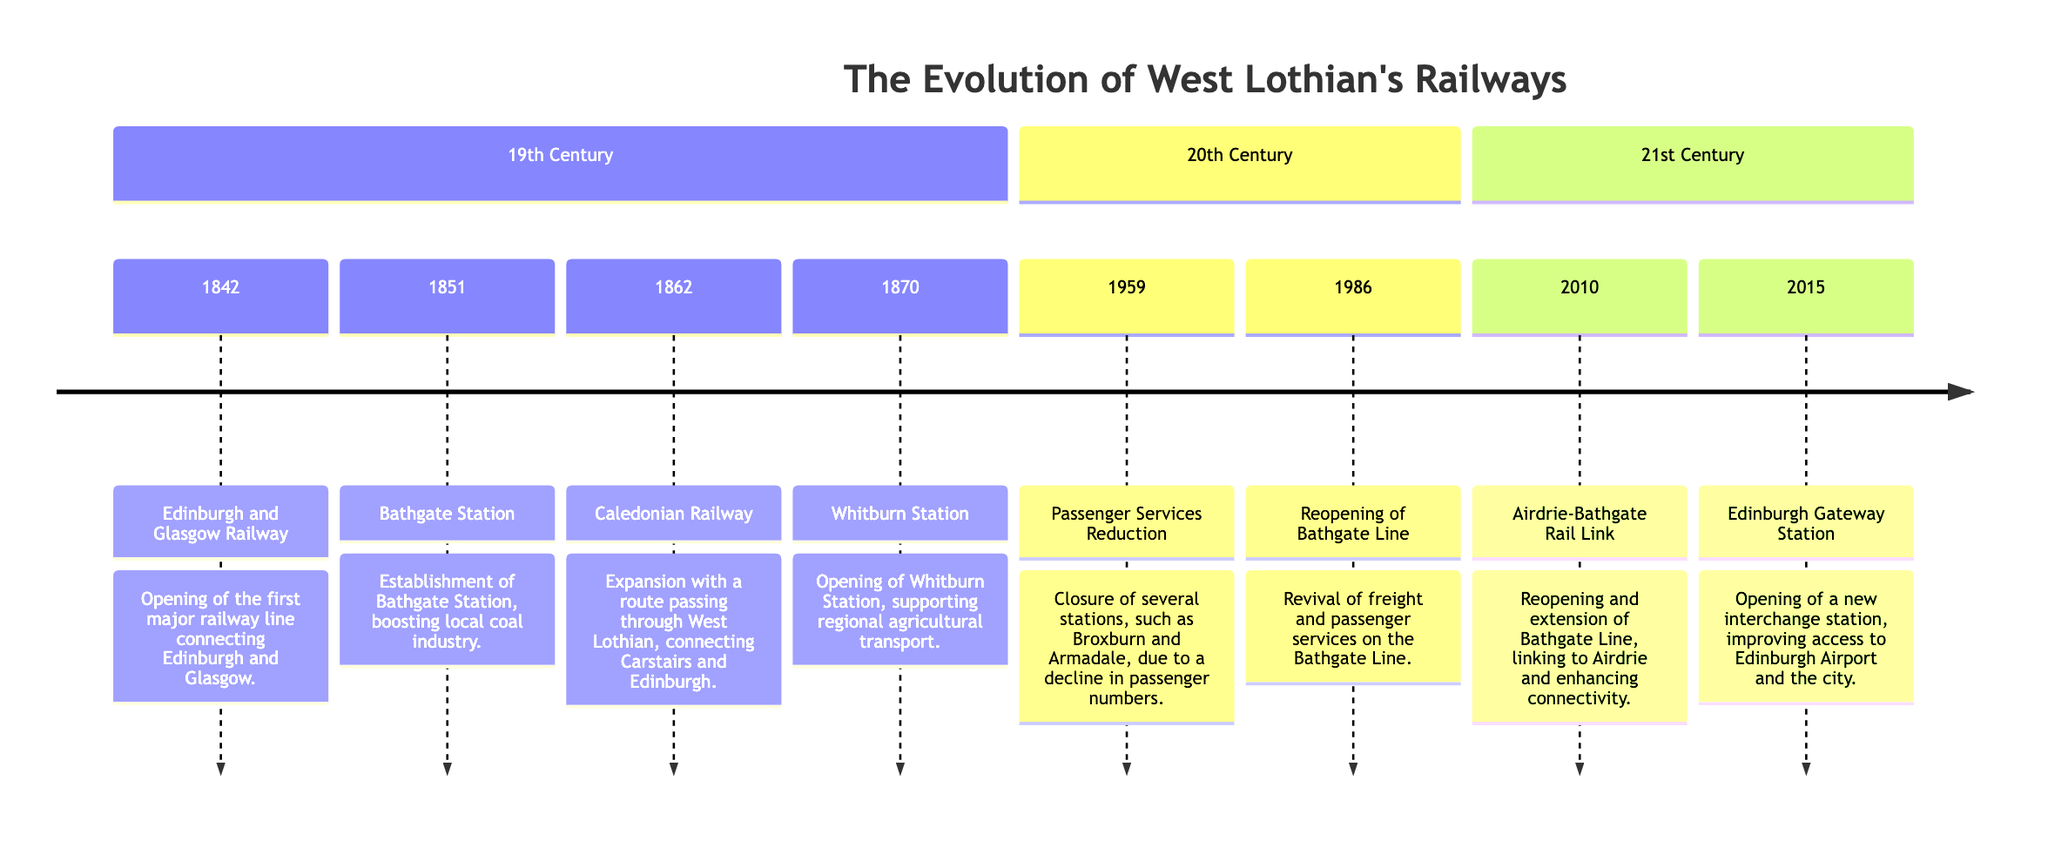What year was the Edinburgh and Glasgow Railway opened? The diagram indicates the opening year of the Edinburgh and Glasgow Railway in the 19th-century section is 1842.
Answer: 1842 Which station was established in 1851? According to the diagram, Bathgate Station is the one established in 1851 in the timeline of the 19th century.
Answer: Bathgate Station How many significant railway events occurred in the 19th century? By counting the number of events listed in the 19th-century section of the diagram, there are four significant railway events.
Answer: 4 What happened in West Lothian in 1959? The diagram mentions that in 1959, there was a reduction of passenger services that led to the closure of stations like Broxburn and Armadale.
Answer: Passenger Services Reduction Which railway line was reopened in 1986? The diagram specifies that the Bathgate Line was reopened in 1986, marking the revival of services in that area.
Answer: Bathgate Line What event took place in 2015? The diagram indicates that Edinburgh Gateway Station was opened in 2015, which improved access to Edinburgh Airport and the city.
Answer: Edinburgh Gateway Station Which two events directly relate to the Bathgate Line? The diagram shows two events for the Bathgate Line: the reopening in 1986 and the Airdrie-Bathgate Rail Link in 2010, linking it with Airdrie.
Answer: Reopening in 1986 and Airdrie-Bathgate Rail Link in 2010 Which station supports regional agricultural transport? The diagram identifies Whitburn Station as the station opened in 1870 that supports regional agricultural transport.
Answer: Whitburn Station What significant change occurred in the railway system from the 19th to the 20th century? The diagram shows a decline in passenger numbers leading to the closure of several stations in the 20th century, showcasing a shift away from active service.
Answer: Closure of several stations 